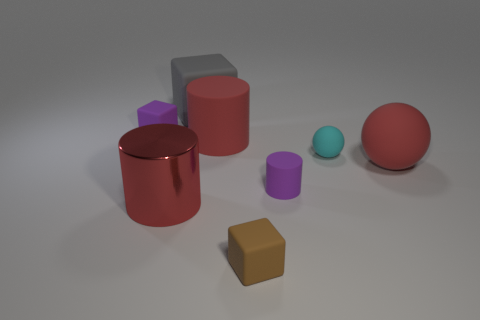Add 2 small spheres. How many objects exist? 10 Subtract all brown matte cubes. How many cubes are left? 2 Add 1 small brown things. How many small brown things are left? 2 Add 5 large rubber things. How many large rubber things exist? 8 Subtract all purple cylinders. How many cylinders are left? 2 Subtract 0 green cylinders. How many objects are left? 8 Subtract all blocks. How many objects are left? 5 Subtract 2 balls. How many balls are left? 0 Subtract all green blocks. Subtract all brown spheres. How many blocks are left? 3 Subtract all purple cubes. How many purple spheres are left? 0 